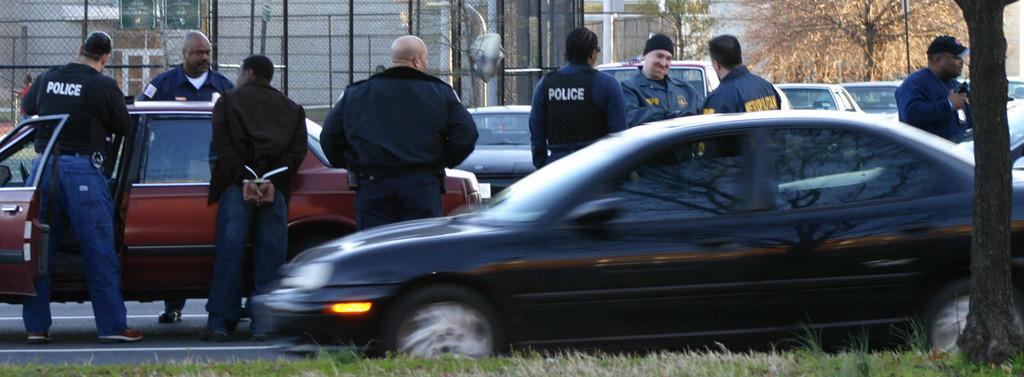What is happening on the road in the image? There are vehicles on a road in the image. What else can be seen in the image besides the vehicles? People are standing in the image. What can be seen in the background of the image? There are trees and fencing in the background of the image. Can you see a desk in the image? No, there is no desk present in the image. Are there any horses in the image? No, there are no horses present in the image. 